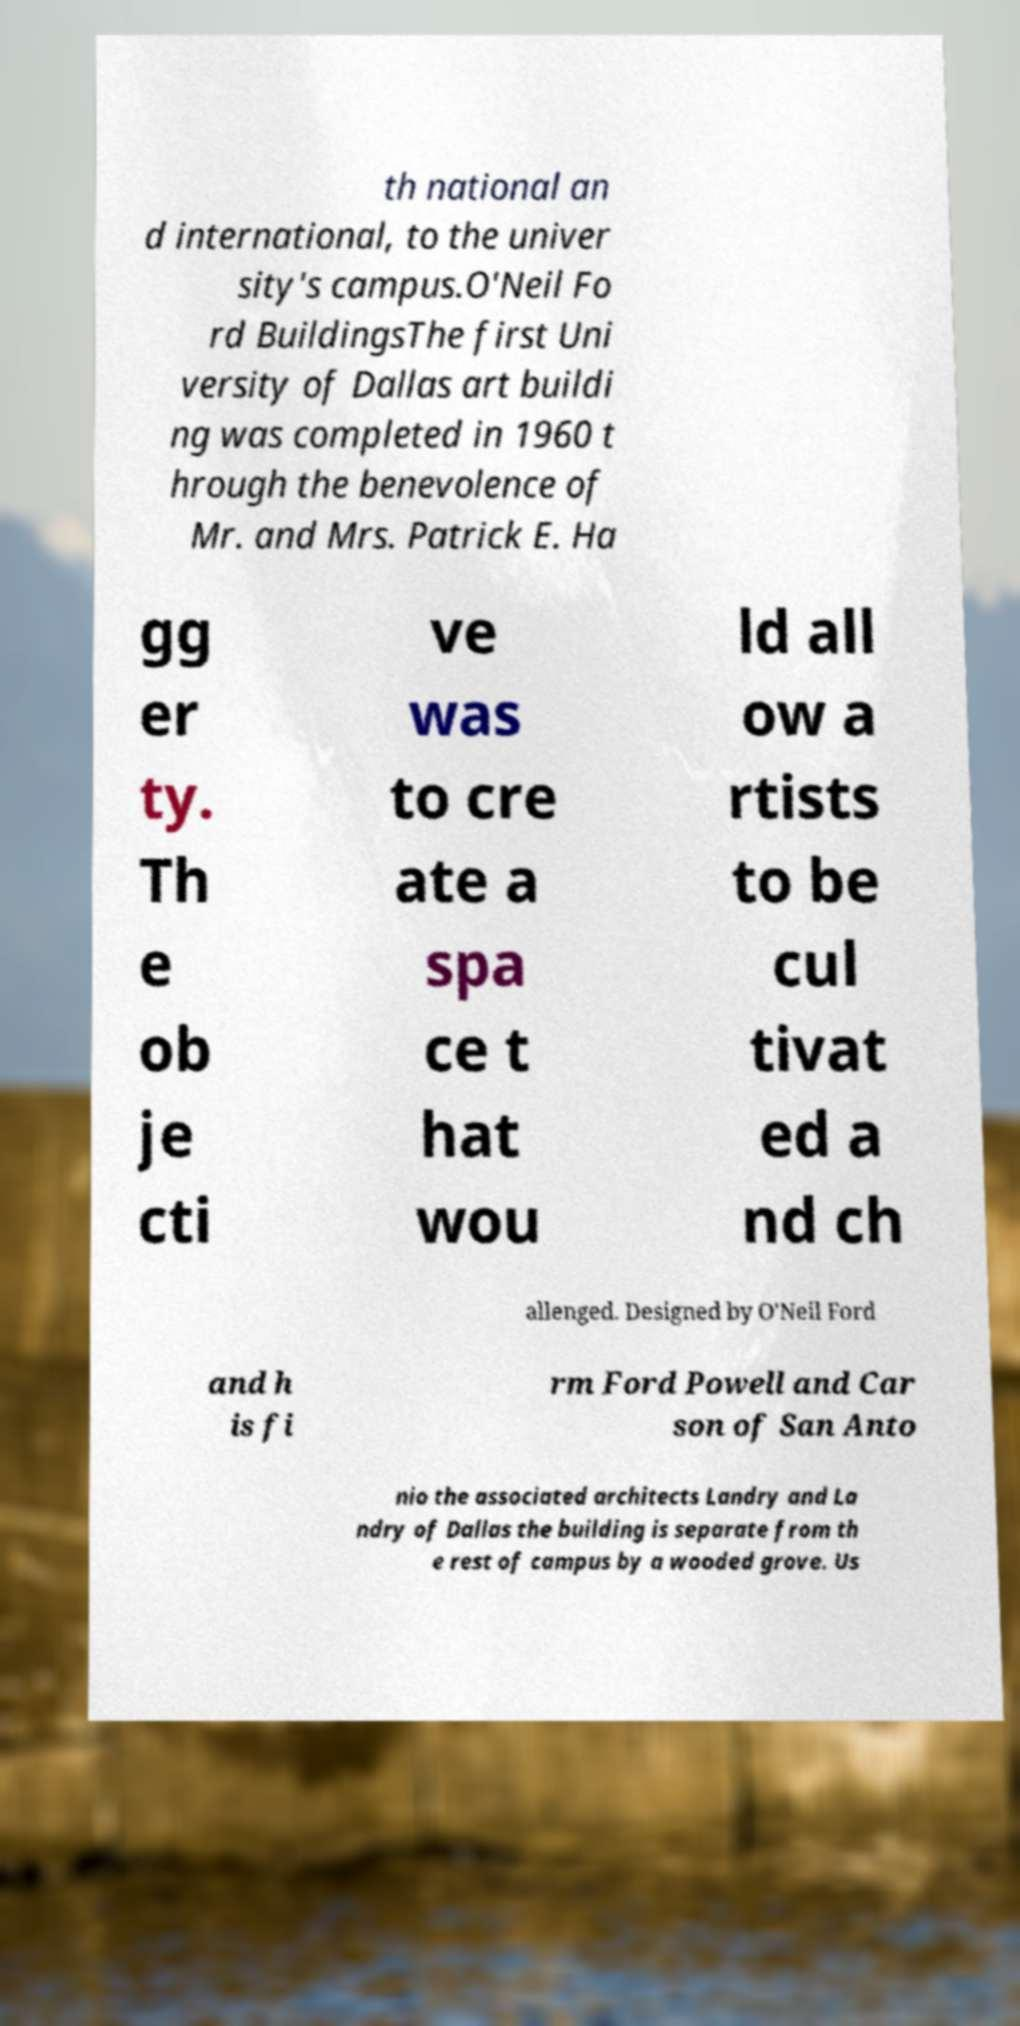What messages or text are displayed in this image? I need them in a readable, typed format. th national an d international, to the univer sity's campus.O'Neil Fo rd BuildingsThe first Uni versity of Dallas art buildi ng was completed in 1960 t hrough the benevolence of Mr. and Mrs. Patrick E. Ha gg er ty. Th e ob je cti ve was to cre ate a spa ce t hat wou ld all ow a rtists to be cul tivat ed a nd ch allenged. Designed by O'Neil Ford and h is fi rm Ford Powell and Car son of San Anto nio the associated architects Landry and La ndry of Dallas the building is separate from th e rest of campus by a wooded grove. Us 